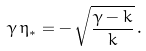<formula> <loc_0><loc_0><loc_500><loc_500>\gamma \, \eta _ { * } = - \, \sqrt { \frac { \gamma - k } { k } } \, .</formula> 